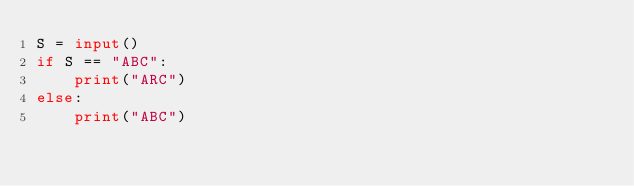<code> <loc_0><loc_0><loc_500><loc_500><_Python_>S = input()
if S == "ABC":
    print("ARC")
else:
    print("ABC")</code> 